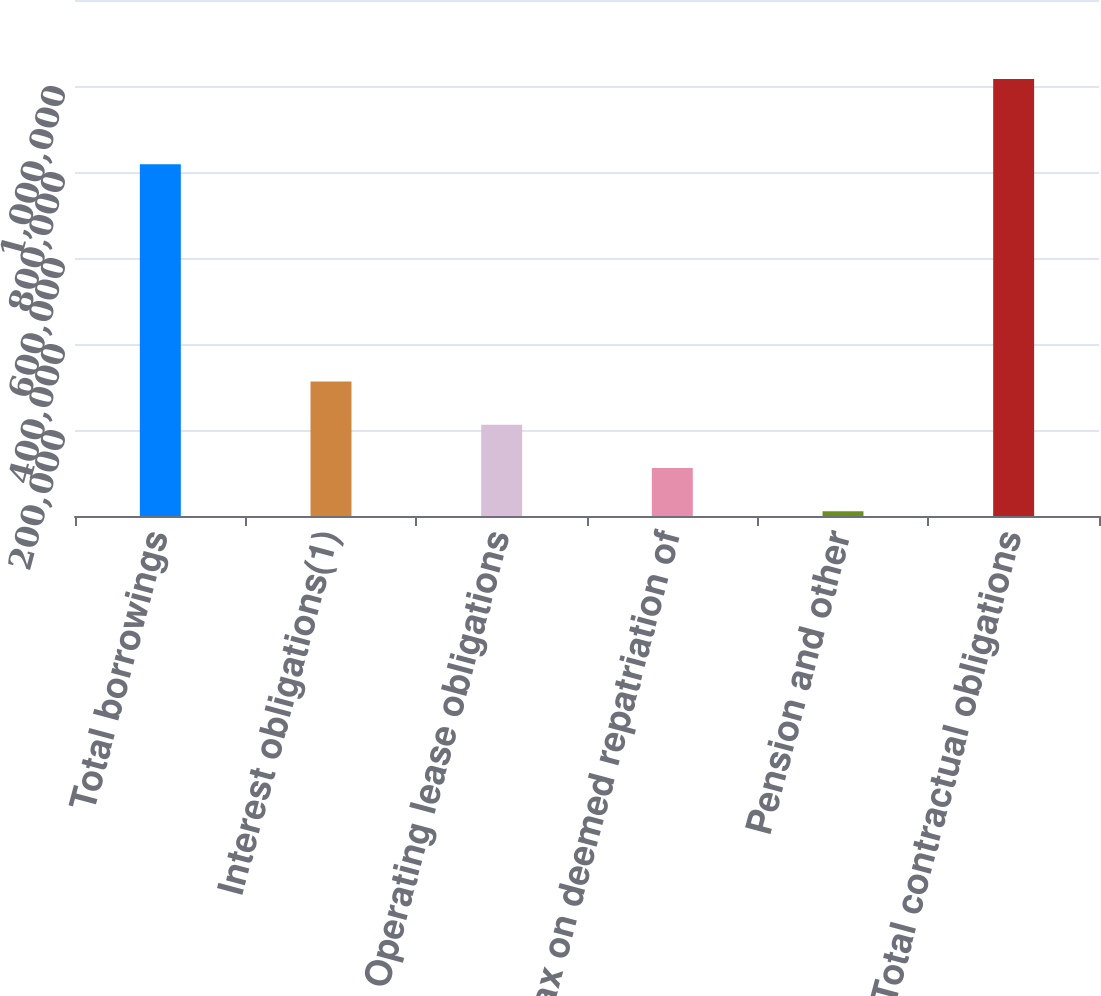<chart> <loc_0><loc_0><loc_500><loc_500><bar_chart><fcel>Total borrowings<fcel>Interest obligations(1)<fcel>Operating lease obligations<fcel>Tax on deemed repatriation of<fcel>Pension and other<fcel>Total contractual obligations<nl><fcel>818000<fcel>312716<fcel>212171<fcel>111625<fcel>11080<fcel>1.01653e+06<nl></chart> 